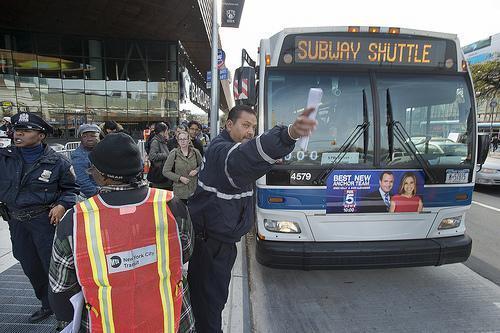How many buses are seen?
Give a very brief answer. 1. 